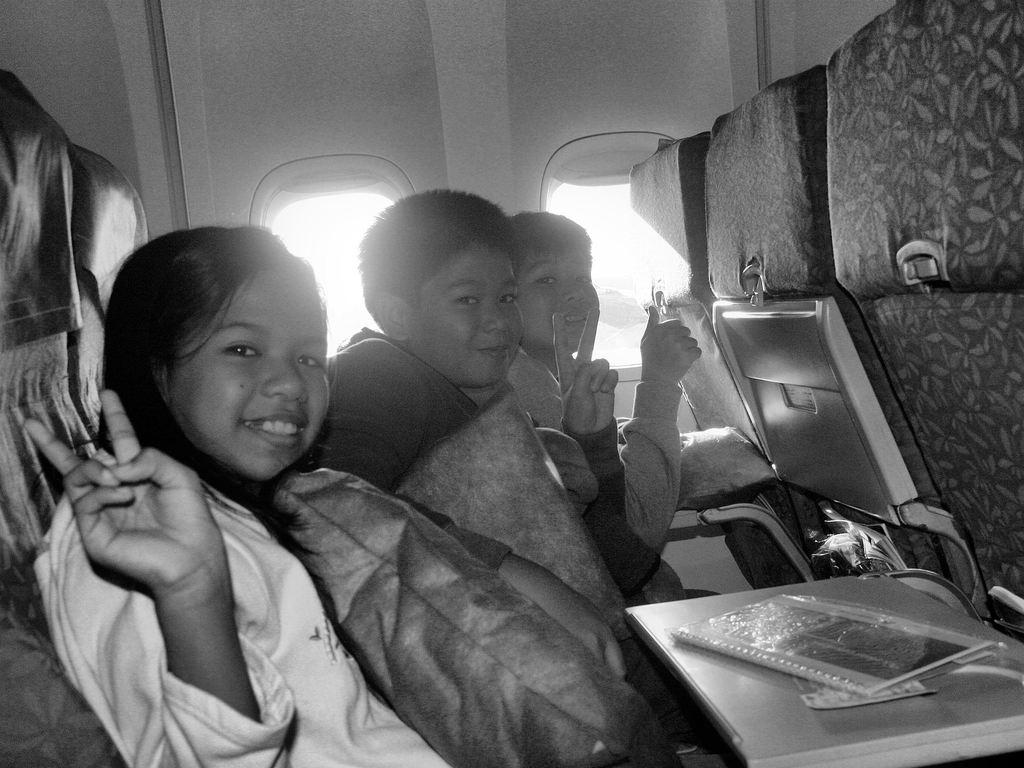How many children are in the image? There are three children in the image. What are the children doing in the image? The children are sitting on a vehicle. What expression do the children have in the image? The children are smiling. What type of cover is protecting the children from the whip in the image? There is no cover or whip present in the image. 